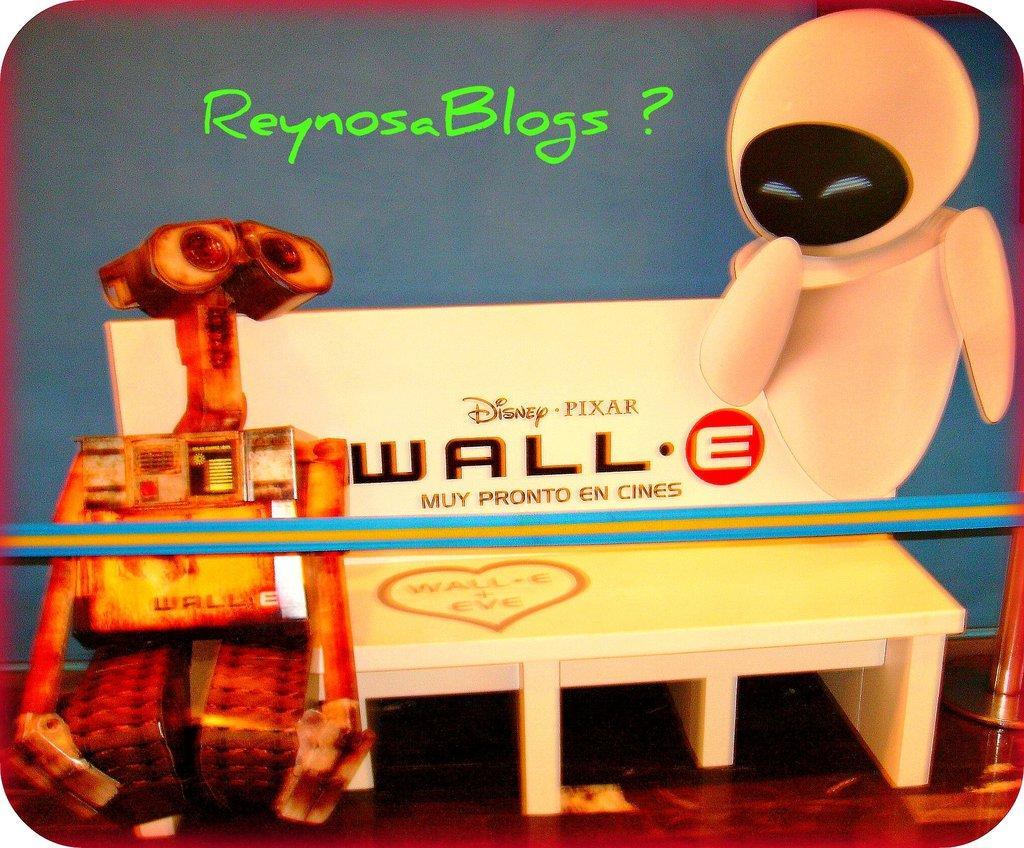Describe this image in one or two sentences. This picture might be a poster. In the right bottom of the picture, we see a robot and behind that, we see a white bench with some text written on it. Behind that, we see a blue wall with text written in green color. 